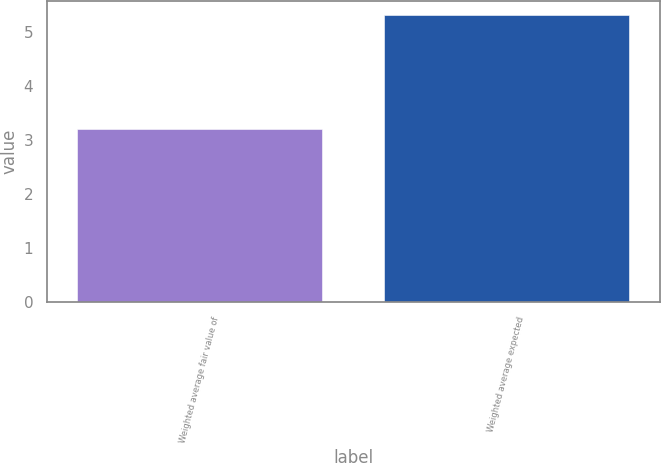Convert chart to OTSL. <chart><loc_0><loc_0><loc_500><loc_500><bar_chart><fcel>Weighted average fair value of<fcel>Weighted average expected<nl><fcel>3.21<fcel>5.3<nl></chart> 